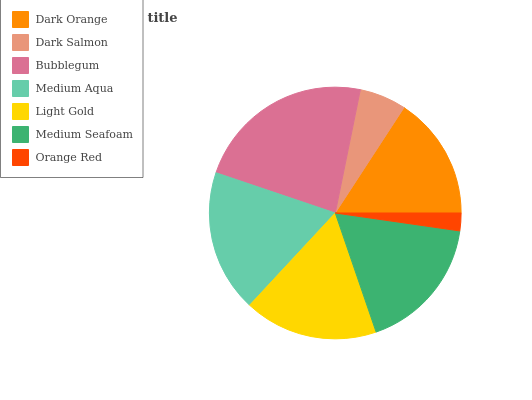Is Orange Red the minimum?
Answer yes or no. Yes. Is Bubblegum the maximum?
Answer yes or no. Yes. Is Dark Salmon the minimum?
Answer yes or no. No. Is Dark Salmon the maximum?
Answer yes or no. No. Is Dark Orange greater than Dark Salmon?
Answer yes or no. Yes. Is Dark Salmon less than Dark Orange?
Answer yes or no. Yes. Is Dark Salmon greater than Dark Orange?
Answer yes or no. No. Is Dark Orange less than Dark Salmon?
Answer yes or no. No. Is Light Gold the high median?
Answer yes or no. Yes. Is Light Gold the low median?
Answer yes or no. Yes. Is Dark Salmon the high median?
Answer yes or no. No. Is Bubblegum the low median?
Answer yes or no. No. 